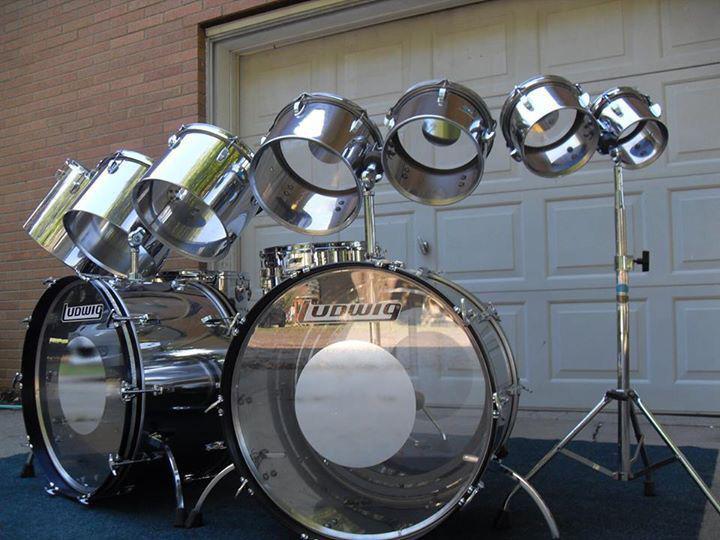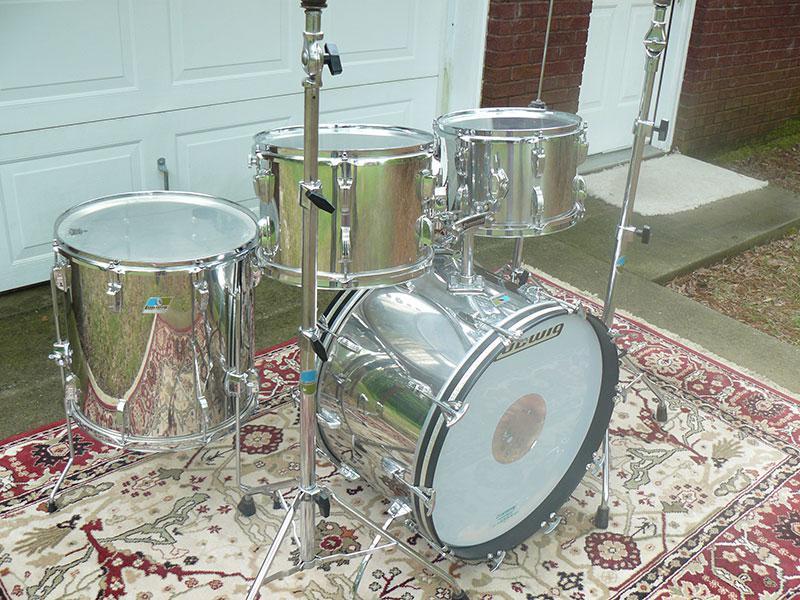The first image is the image on the left, the second image is the image on the right. For the images displayed, is the sentence "There are three kick drums." factually correct? Answer yes or no. Yes. 